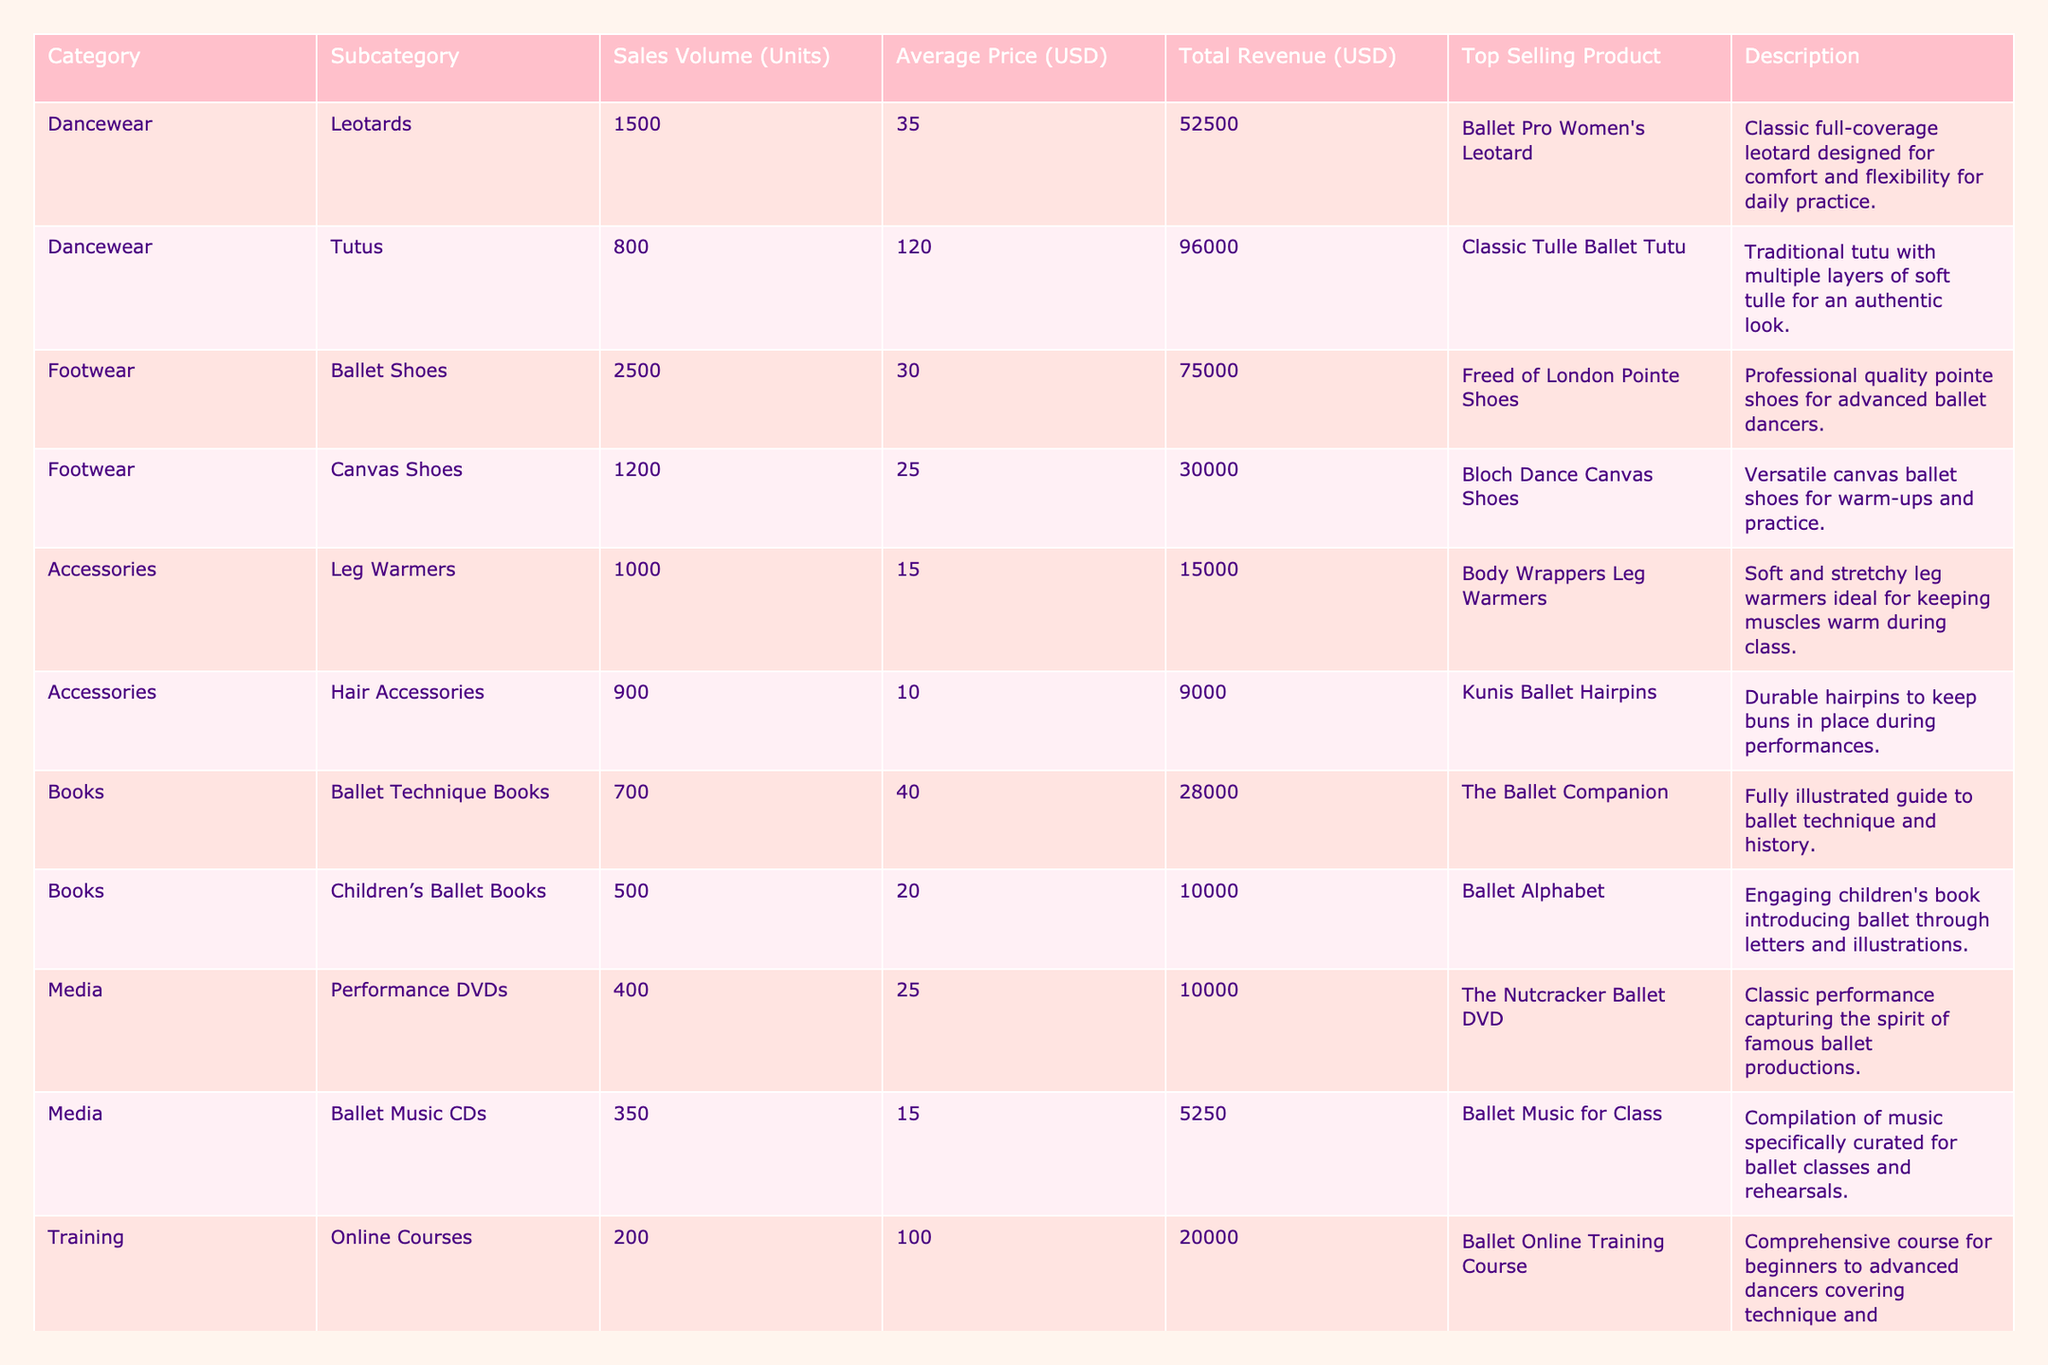What is the total revenue generated from ballet shoes sales? According to the table, the total revenue for ballet shoes is listed as $75,000.
Answer: $75,000 Which category has the highest sales volume? The table shows that footwear, specifically ballet shoes, has the highest sales volume with 2,500 units sold.
Answer: Footwear What is the average price of tutus? The table indicates that the average price for tutus is $120.
Answer: $120 How many units of children's ballet books were sold? The table lists the number of units sold for children’s ballet books as 500.
Answer: 500 What is the total number of units sold across all categories? By summing the sales volumes from all categories: 1500 (leotards) + 800 (tutus) + 2500 (ballet shoes) + 1200 (canvas shoes) + 1000 (leg warmers) + 900 (hair accessories) + 700 (ballet technique books) + 500 (children's books) + 400 (performance DVDs) + 350 (music CDs) + 200 (online courses) + 300 (workshops) gives a total of 10,000 units sold.
Answer: 10,000 Is the average price of dancewear items higher than that of accessories? To determine this, we calculate the average price of dancewear: (35 + 120) / 2 = 77.5, and for accessories: (15 + 10) / 2 = 12.5. Since 77.5 is greater than 12.5, the answer is yes.
Answer: Yes What percentage of the total revenue came from the sales of tutus? First, the total revenue across all categories is calculated as $52500 + $96000 + $75000 + $30000 + $15000 + $9000 + $28000 + $10000 + $10000 + $5250 + $20000 + $45000 = $382,750. The revenue from tutus is $96,000. The percentage is then ($96,000 / $382,750) * 100, which is approximately 25.1%.
Answer: 25.1% How many more ballet shoes were sold than online courses? The number of ballet shoes sold is 2,500 and online courses sold is 200, so the difference is 2,500 - 200 = 2,300.
Answer: 2,300 Which subcategory generated the least revenue? Checking the total revenue figures, ballet music CDs generated the least at $5,250.
Answer: Ballet Music CDs Are there more units sold in the footwear category than in the training category? Footwear sales total 3,700 units (2,500 ballet shoes + 1,200 canvas shoes), while training sales total 500 units (200 online courses + 300 workshops). Since 3,700 is greater than 500, the answer is yes.
Answer: Yes What is the combined revenue from the two subcategories within books? The revenue from ballet technique books is $28,000 and from children’s ballet books is $10,000. Combining these gives $28,000 + $10,000 = $38,000.
Answer: $38,000 